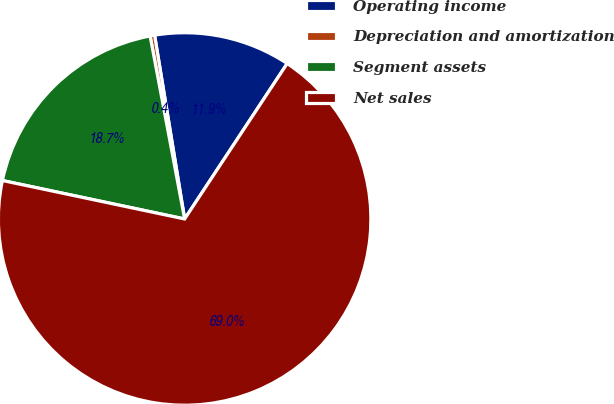Convert chart to OTSL. <chart><loc_0><loc_0><loc_500><loc_500><pie_chart><fcel>Operating income<fcel>Depreciation and amortization<fcel>Segment assets<fcel>Net sales<nl><fcel>11.86%<fcel>0.39%<fcel>18.72%<fcel>69.03%<nl></chart> 